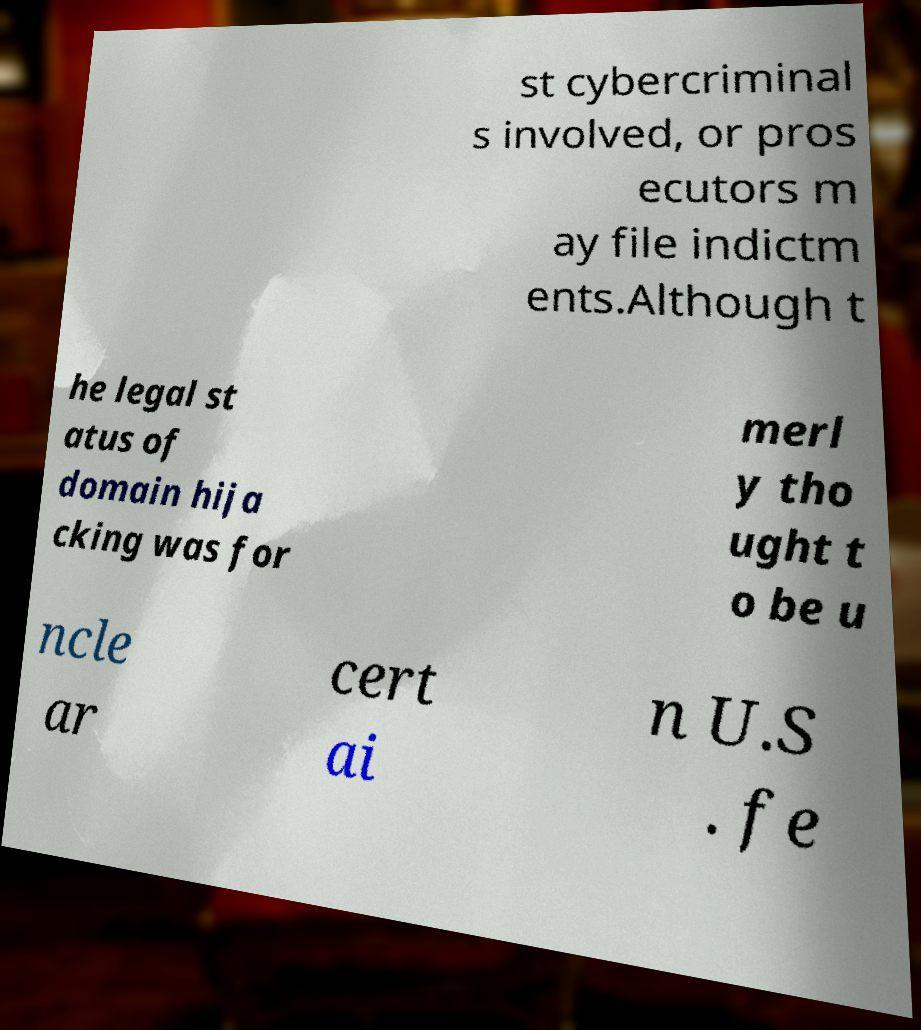Could you assist in decoding the text presented in this image and type it out clearly? st cybercriminal s involved, or pros ecutors m ay file indictm ents.Although t he legal st atus of domain hija cking was for merl y tho ught t o be u ncle ar cert ai n U.S . fe 